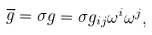<formula> <loc_0><loc_0><loc_500><loc_500>\overline { g } = \sigma g = \sigma g _ { i j } \omega ^ { i } \omega ^ { j } ,</formula> 